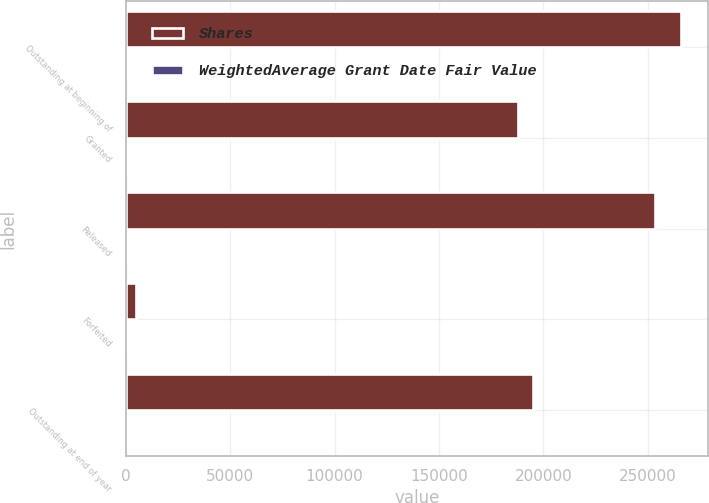Convert chart. <chart><loc_0><loc_0><loc_500><loc_500><stacked_bar_chart><ecel><fcel>Outstanding at beginning of<fcel>Granted<fcel>Released<fcel>Forfeited<fcel>Outstanding at end of year<nl><fcel>Shares<fcel>265829<fcel>187794<fcel>253484<fcel>4980<fcel>195159<nl><fcel>WeightedAverage Grant Date Fair Value<fcel>35.55<fcel>35.17<fcel>27.9<fcel>41.46<fcel>42.25<nl></chart> 